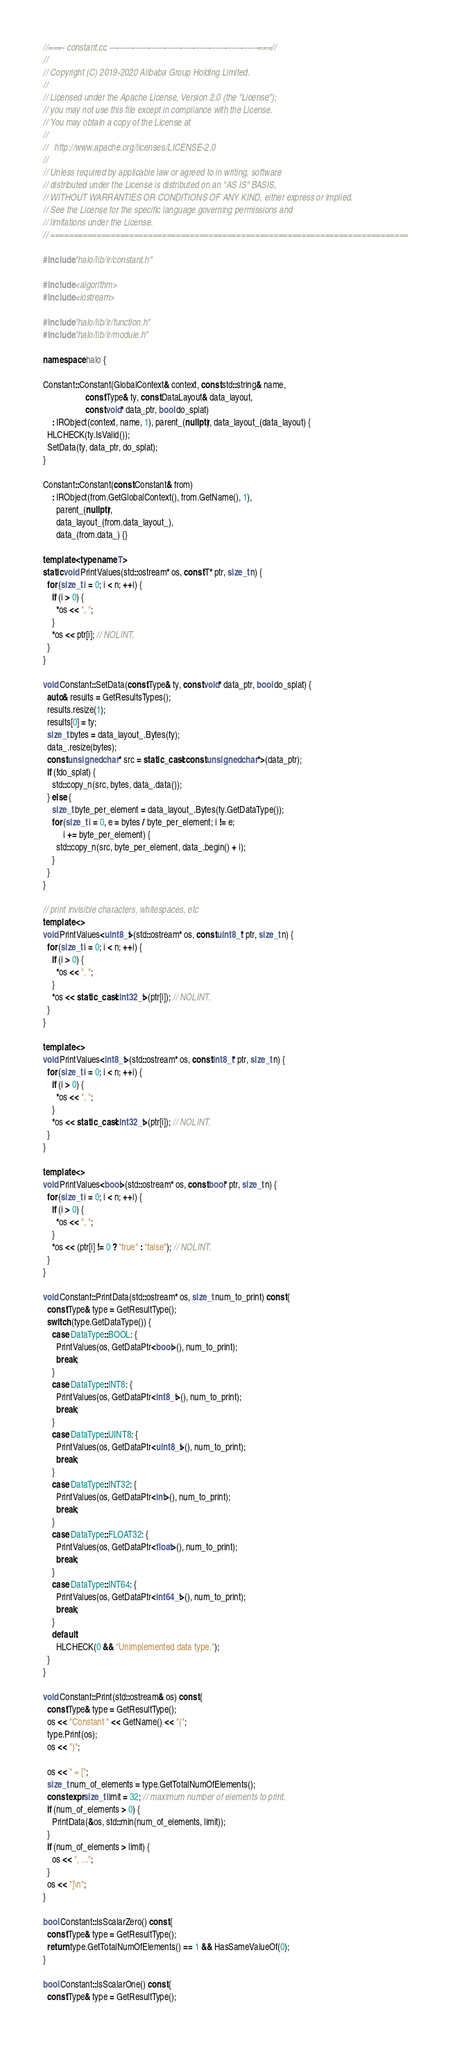<code> <loc_0><loc_0><loc_500><loc_500><_C++_>//===- constant.cc --------------------------------------------------------===//
//
// Copyright (C) 2019-2020 Alibaba Group Holding Limited.
//
// Licensed under the Apache License, Version 2.0 (the "License");
// you may not use this file except in compliance with the License.
// You may obtain a copy of the License at
//
//   http://www.apache.org/licenses/LICENSE-2.0
//
// Unless required by applicable law or agreed to in writing, software
// distributed under the License is distributed on an "AS IS" BASIS,
// WITHOUT WARRANTIES OR CONDITIONS OF ANY KIND, either express or implied.
// See the License for the specific language governing permissions and
// limitations under the License.
// =============================================================================

#include "halo/lib/ir/constant.h"

#include <algorithm>
#include <iostream>

#include "halo/lib/ir/function.h"
#include "halo/lib/ir/module.h"

namespace halo {

Constant::Constant(GlobalContext& context, const std::string& name,
                   const Type& ty, const DataLayout& data_layout,
                   const void* data_ptr, bool do_splat)
    : IRObject(context, name, 1), parent_(nullptr), data_layout_(data_layout) {
  HLCHECK(ty.IsValid());
  SetData(ty, data_ptr, do_splat);
}

Constant::Constant(const Constant& from)
    : IRObject(from.GetGlobalContext(), from.GetName(), 1),
      parent_(nullptr),
      data_layout_(from.data_layout_),
      data_(from.data_) {}

template <typename T>
static void PrintValues(std::ostream* os, const T* ptr, size_t n) {
  for (size_t i = 0; i < n; ++i) {
    if (i > 0) {
      *os << ", ";
    }
    *os << ptr[i]; // NOLINT.
  }
}

void Constant::SetData(const Type& ty, const void* data_ptr, bool do_splat) {
  auto& results = GetResultsTypes();
  results.resize(1);
  results[0] = ty;
  size_t bytes = data_layout_.Bytes(ty);
  data_.resize(bytes);
  const unsigned char* src = static_cast<const unsigned char*>(data_ptr);
  if (!do_splat) {
    std::copy_n(src, bytes, data_.data());
  } else {
    size_t byte_per_element = data_layout_.Bytes(ty.GetDataType());
    for (size_t i = 0, e = bytes / byte_per_element; i != e;
         i += byte_per_element) {
      std::copy_n(src, byte_per_element, data_.begin() + i);
    }
  }
}

// print invisible characters, whitespaces, etc
template <>
void PrintValues<uint8_t>(std::ostream* os, const uint8_t* ptr, size_t n) {
  for (size_t i = 0; i < n; ++i) {
    if (i > 0) {
      *os << ", ";
    }
    *os << static_cast<int32_t>(ptr[i]); // NOLINT.
  }
}

template <>
void PrintValues<int8_t>(std::ostream* os, const int8_t* ptr, size_t n) {
  for (size_t i = 0; i < n; ++i) {
    if (i > 0) {
      *os << ", ";
    }
    *os << static_cast<int32_t>(ptr[i]); // NOLINT.
  }
}

template <>
void PrintValues<bool>(std::ostream* os, const bool* ptr, size_t n) {
  for (size_t i = 0; i < n; ++i) {
    if (i > 0) {
      *os << ", ";
    }
    *os << (ptr[i] != 0 ? "true" : "false"); // NOLINT.
  }
}

void Constant::PrintData(std::ostream* os, size_t num_to_print) const {
  const Type& type = GetResultType();
  switch (type.GetDataType()) {
    case DataType::BOOL: {
      PrintValues(os, GetDataPtr<bool>(), num_to_print);
      break;
    }
    case DataType::INT8: {
      PrintValues(os, GetDataPtr<int8_t>(), num_to_print);
      break;
    }
    case DataType::UINT8: {
      PrintValues(os, GetDataPtr<uint8_t>(), num_to_print);
      break;
    }
    case DataType::INT32: {
      PrintValues(os, GetDataPtr<int>(), num_to_print);
      break;
    }
    case DataType::FLOAT32: {
      PrintValues(os, GetDataPtr<float>(), num_to_print);
      break;
    }
    case DataType::INT64: {
      PrintValues(os, GetDataPtr<int64_t>(), num_to_print);
      break;
    }
    default:
      HLCHECK(0 && "Unimplemented data type.");
  }
}

void Constant::Print(std::ostream& os) const {
  const Type& type = GetResultType();
  os << "Constant " << GetName() << "(";
  type.Print(os);
  os << ")";

  os << " = [";
  size_t num_of_elements = type.GetTotalNumOfElements();
  constexpr size_t limit = 32; // maximum number of elements to print.
  if (num_of_elements > 0) {
    PrintData(&os, std::min(num_of_elements, limit));
  }
  if (num_of_elements > limit) {
    os << ", ...";
  }
  os << "]\n";
}

bool Constant::IsScalarZero() const {
  const Type& type = GetResultType();
  return type.GetTotalNumOfElements() == 1 && HasSameValueOf(0);
}

bool Constant::IsScalarOne() const {
  const Type& type = GetResultType();</code> 